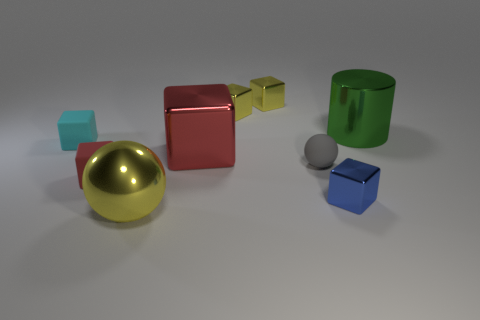Subtract all gray spheres. How many spheres are left? 1 Subtract all red matte blocks. How many blocks are left? 5 Subtract all red blocks. How many yellow balls are left? 1 Add 1 small red cylinders. How many small red cylinders exist? 1 Subtract 1 yellow spheres. How many objects are left? 8 Subtract all cylinders. How many objects are left? 8 Subtract 1 cylinders. How many cylinders are left? 0 Subtract all blue balls. Subtract all green blocks. How many balls are left? 2 Subtract all tiny gray spheres. Subtract all tiny gray balls. How many objects are left? 7 Add 2 big red metallic blocks. How many big red metallic blocks are left? 3 